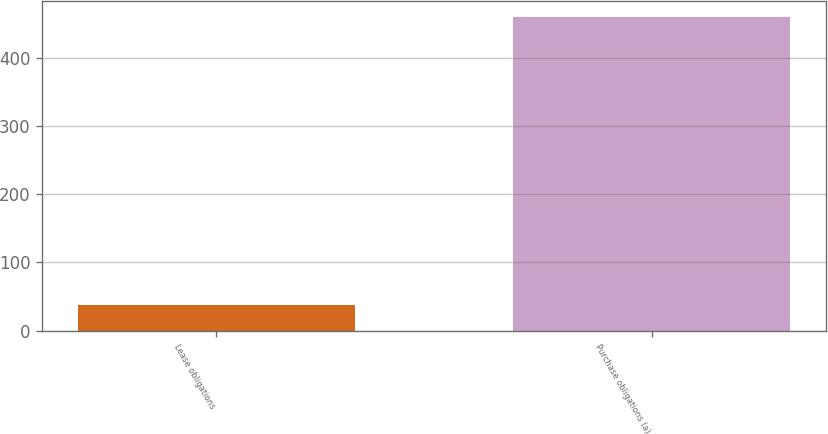<chart> <loc_0><loc_0><loc_500><loc_500><bar_chart><fcel>Lease obligations<fcel>Purchase obligations (a)<nl><fcel>38<fcel>460<nl></chart> 